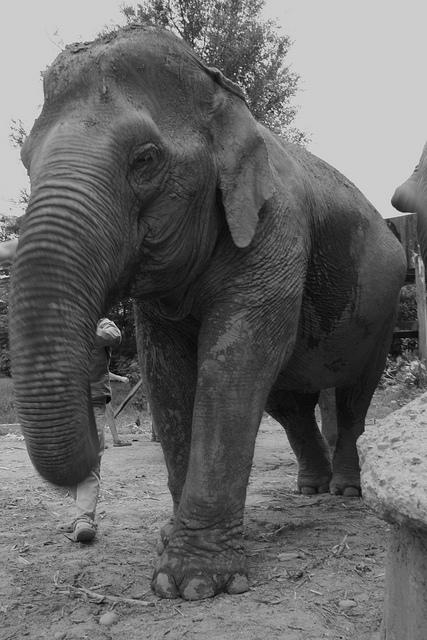Can you see trees?
Be succinct. Yes. How many elephant is in the picture?
Write a very short answer. 1. What is the elephant doing with its trunk?
Give a very brief answer. Curling it. What is the elephant doing?
Answer briefly. Walking. Is there a person in the picture?
Short answer required. No. 